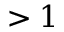<formula> <loc_0><loc_0><loc_500><loc_500>> 1</formula> 